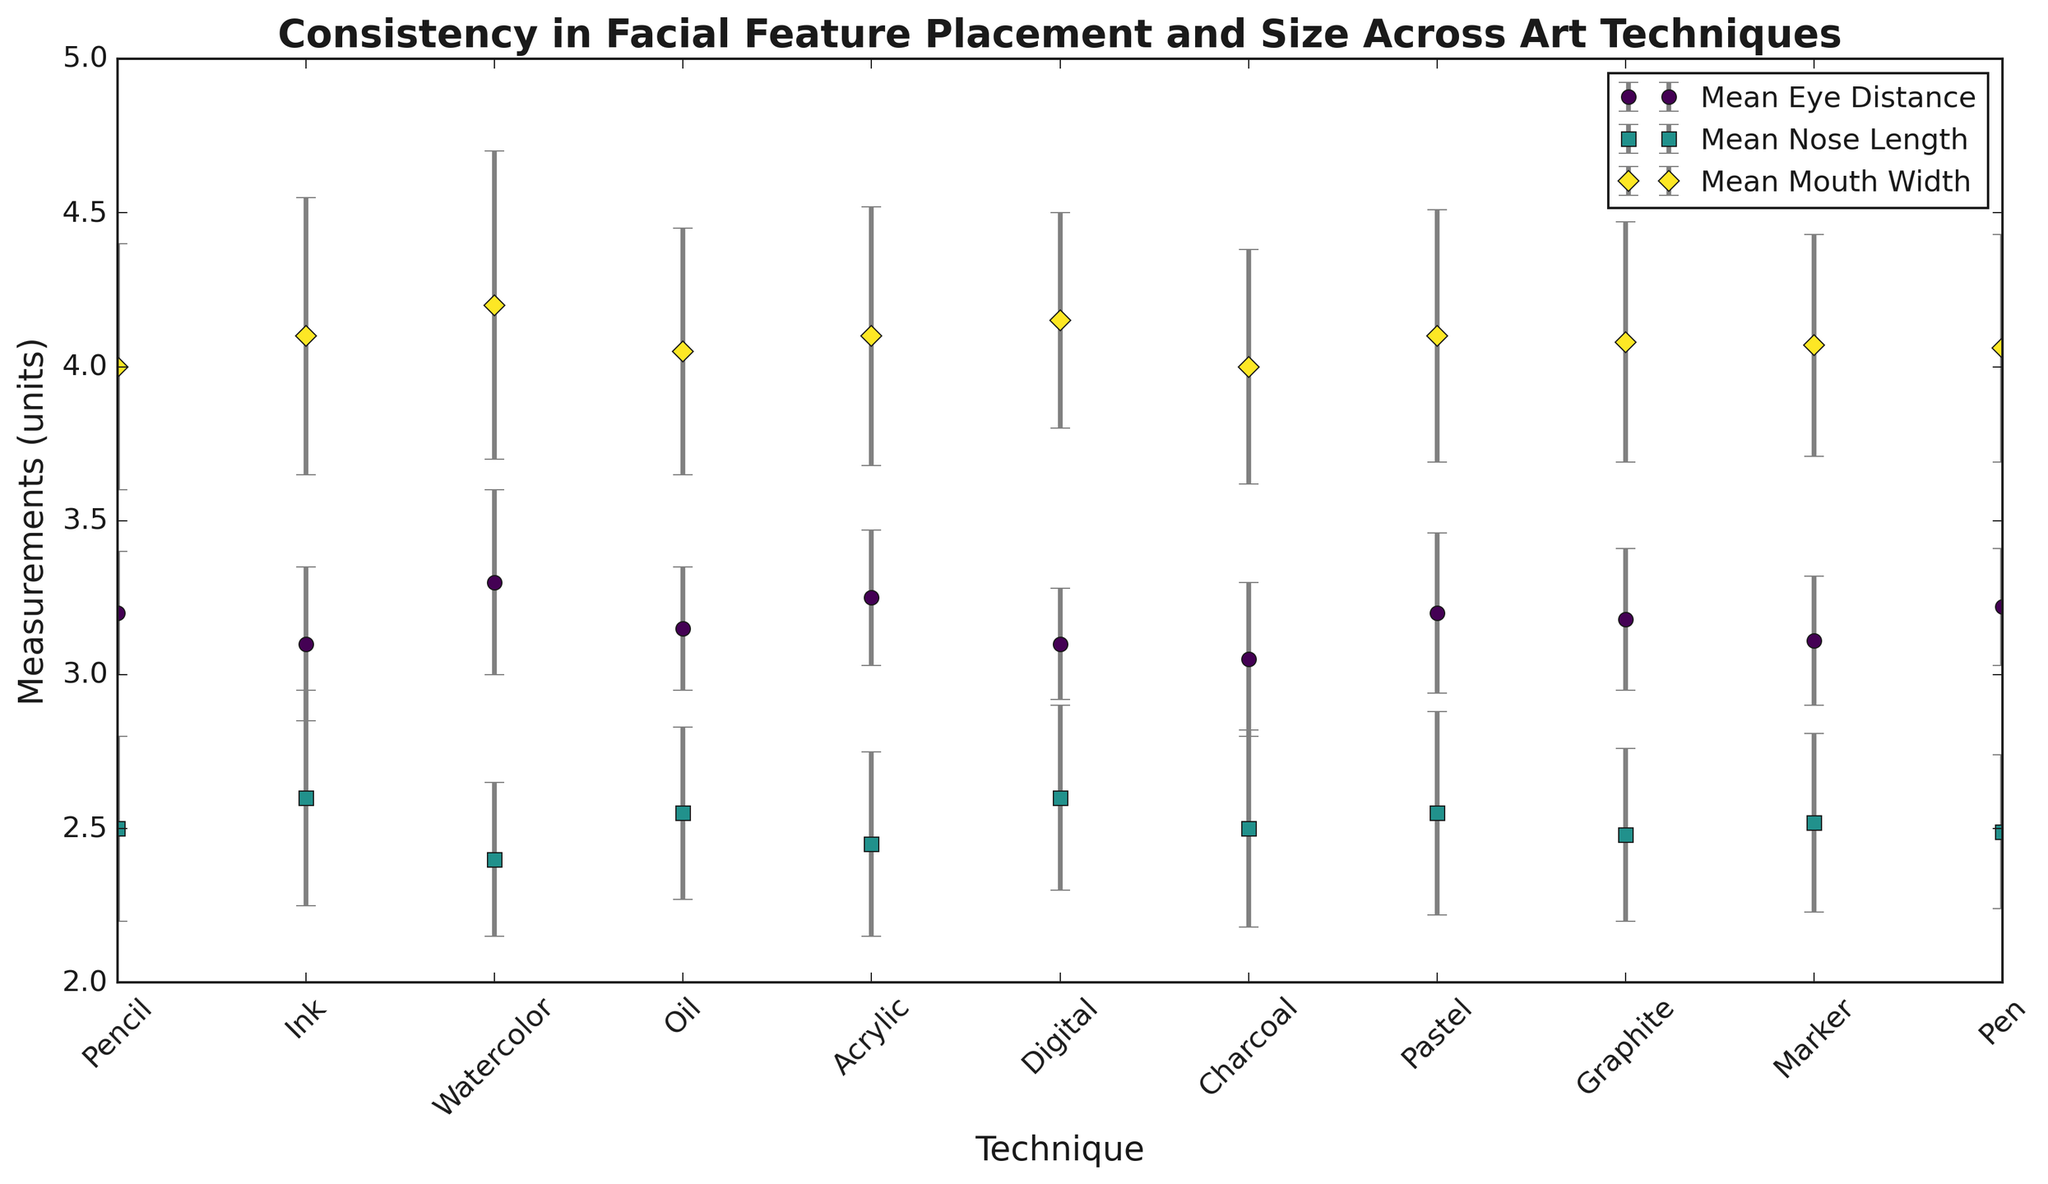Which art technique displayed the highest mean eye distance? Looking at the figure, the technique with the highest mean eye distance is represented by the uppermost point along the y-axis for Mean Eye Distance. Analyzing the points, Watercolor has the highest mean eye distance.
Answer: Watercolor Which technique shows the greatest variability in mouth width? Variability is indicated by the length of the error bars. The longest error bars for Mean Mouth Width show the highest variability. Watercolor has the longest error bars for mouth width.
Answer: Watercolor Compare the mean nose length between Pencil and Acrylic techniques. Which is greater? The mean nose length for Pencil and Acrylic can be compared by looking at their respective points on the graph labeled Mean Nose Length. Pencil has a mean nose length of 2.5, whereas Acrylic has 2.45. Thus, Pencil has a greater mean nose length.
Answer: Pencil Which technique has the smallest standard deviation for eye distance? The smallest standard deviation can be found by looking for the shortest error bars representing the standard deviation of Mean Eye Distance. Digital has the smallest standard deviation for eye distance.
Answer: Digital Is the mean eye distance for Graphite greater or less than that for Ink? Comparing the positions of the points for Graphite and Ink under Mean Eye Distance, Graphite (3.18) is greater than Ink (3.1).
Answer: Greater Which two techniques have the closest mean mouth width? To find the closest mean mouth widths, look for techniques with points that are nearest to each other in the Mean Mouth Width plot. Graphite (4.08) and Marker (4.07) have the closest mean mouth widths.
Answer: Graphite and Marker Calculate the average mean nose length across all techniques. To calculate the average, sum up all the mean nose lengths and divide by the number of techniques. The mean nose lengths are 2.5, 2.6, 2.4, 2.55, 2.45, 2.6, 2.5, 2.55, 2.48, 2.52, and 2.49.
Sum = 2.5 + 2.6 + 2.4 + 2.55 + 2.45 + 2.6 + 2.5 + 2.55 + 2.48 + 2.52 + 2.49 = 28.14
Number of techniques = 11
Average = 28.14 / 11 ≈ 2.56
Answer: 2.56 Looking at the standard deviations for mouth width, which technique exhibits the least variability? The technique with the shortest error bars for Mean Mouth Width represents the least variability. Digital has the smallest standard deviation for mouth width.
Answer: Digital Between Oil and Charcoal, which technique has a larger mean eye distance? Comparing the mean eye distance values for Oil (3.15) and Charcoal (3.05), Oil has a larger mean eye distance.
Answer: Oil Which measurement (eye distance, nose length, or mouth width) shows the highest overall variability across all techniques? Overall variability can be assessed by observing the length of the error bars for each measurement. The highest error bars across all techniques are seen in Mean Mouth Width, indicating it has the highest overall variability.
Answer: Mouth Width 